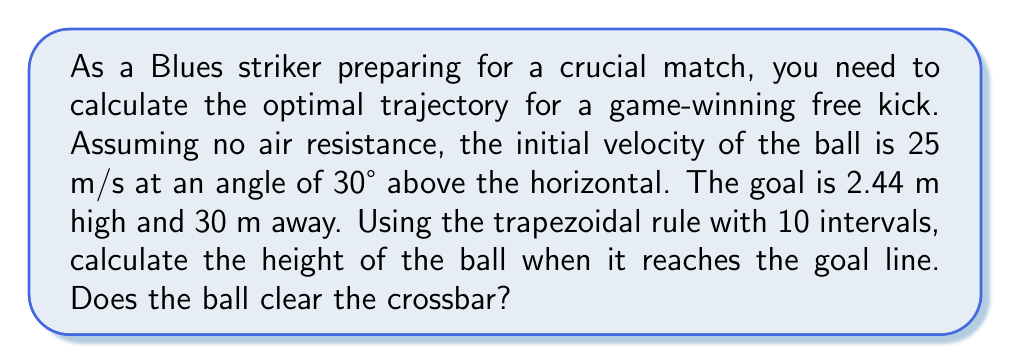What is the answer to this math problem? Let's approach this step-by-step:

1) The equations of motion for projectile motion are:
   $$x(t) = v_0 \cos(\theta) \cdot t$$
   $$y(t) = v_0 \sin(\theta) \cdot t - \frac{1}{2}gt^2$$

   Where $v_0 = 25$ m/s, $\theta = 30°$, and $g = 9.8$ m/s².

2) We need to find the time when the ball reaches the goal line. Using the x-equation:
   $$30 = 25 \cos(30°) \cdot t$$
   $$t = \frac{30}{25 \cos(30°)} \approx 2.77 \text{ s}$$

3) Now, we need to calculate y(t) using numerical integration. The trapezoidal rule is:

   $$\int_{a}^{b} f(x)dx \approx \frac{b-a}{2n}[f(x_0) + 2f(x_1) + 2f(x_2) + ... + 2f(x_{n-1}) + f(x_n)]$$

   Where $f(t) = v_0 \sin(\theta) - gt = 25 \sin(30°) - 9.8t$

4) We'll divide the time interval [0, 2.77] into 10 subintervals:
   $$\Delta t = \frac{2.77}{10} = 0.277$$

5) Calculate $f(t)$ at each point:
   $f(0) = 12.5$
   $f(0.277) = 9.79$
   $f(0.554) = 7.07$
   ...
   $f(2.77) = -14.65$

6) Apply the trapezoidal rule:
   $$y(2.77) \approx \frac{0.277}{2}[12.5 + 2(9.79 + 7.07 + ... ) - 14.65]$$

7) Calculating this gives us:
   $$y(2.77) \approx 2.84 \text{ m}$$

8) Since 2.84 m > 2.44 m, the ball clears the crossbar.
Answer: 2.84 m; Yes 